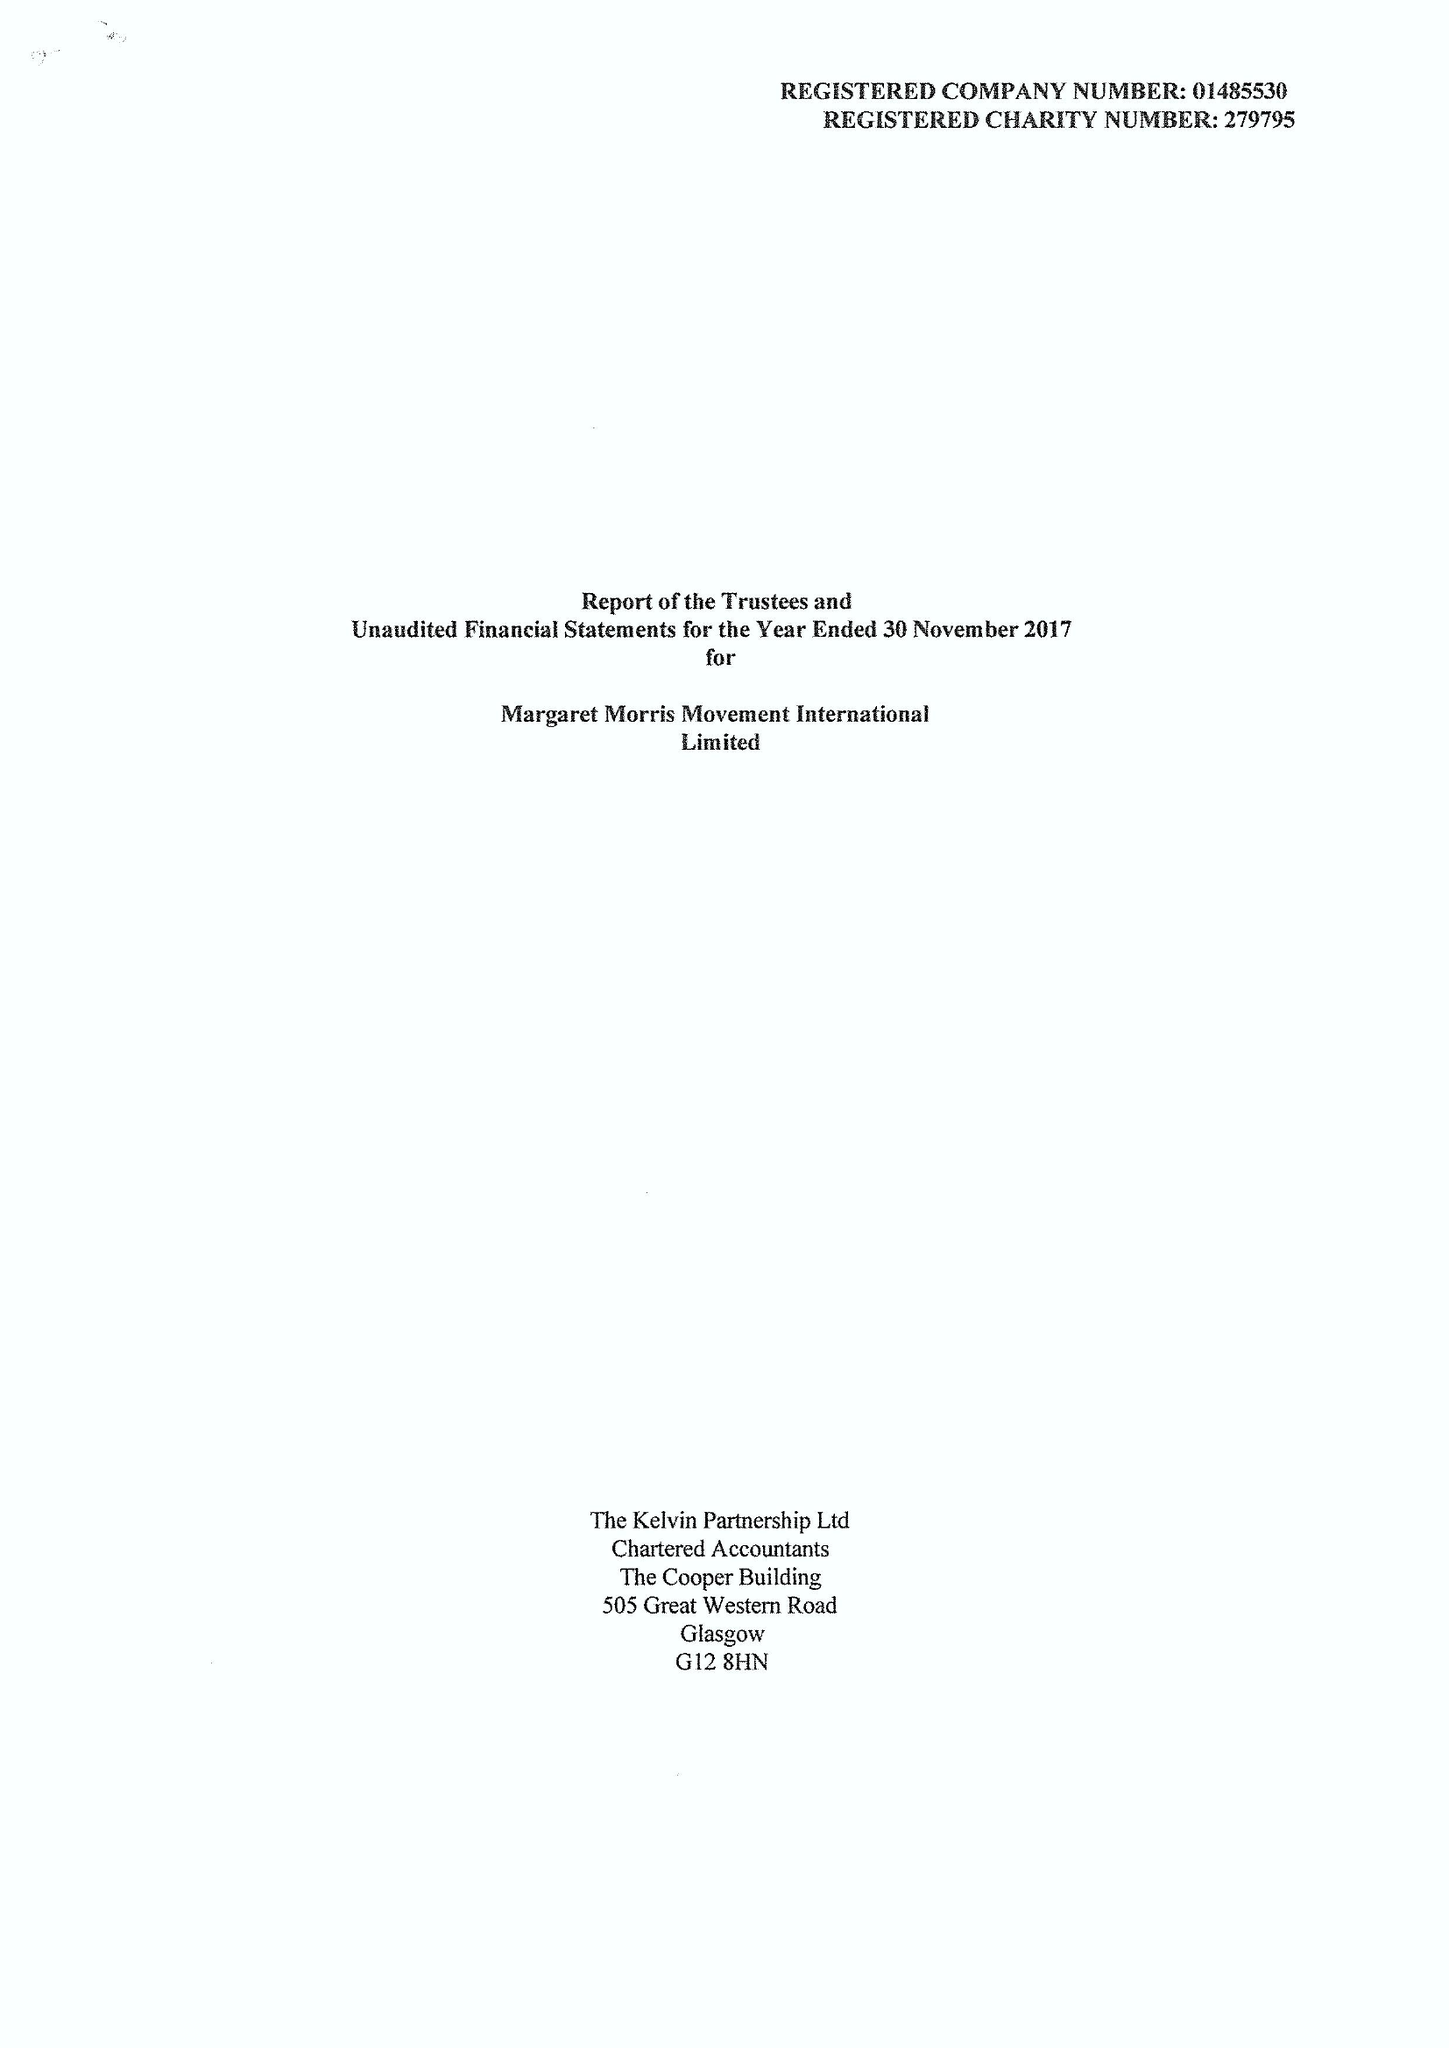What is the value for the charity_name?
Answer the question using a single word or phrase. Margaret Morris Movement International Ltd. 